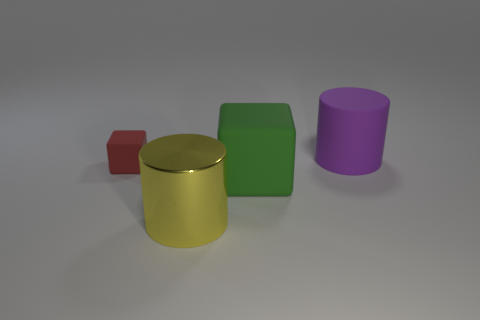There is a purple rubber cylinder; are there any purple cylinders on the left side of it?
Offer a terse response. No. Are there more objects than yellow cylinders?
Your response must be concise. Yes. There is a big cylinder that is to the left of the cube on the right side of the cylinder that is in front of the green block; what color is it?
Make the answer very short. Yellow. What color is the tiny thing that is made of the same material as the big green object?
Make the answer very short. Red. Is there any other thing that has the same size as the yellow thing?
Your answer should be compact. Yes. How many objects are either cylinders that are behind the shiny object or cylinders that are behind the yellow cylinder?
Make the answer very short. 1. There is a block that is right of the big yellow cylinder; is it the same size as the cylinder that is in front of the rubber cylinder?
Your response must be concise. Yes. What color is the other rubber object that is the same shape as the green matte thing?
Provide a succinct answer. Red. Are there any other things that are the same shape as the tiny rubber thing?
Provide a succinct answer. Yes. Are there more big green rubber objects that are on the right side of the large purple cylinder than big purple things in front of the tiny block?
Your response must be concise. No. 